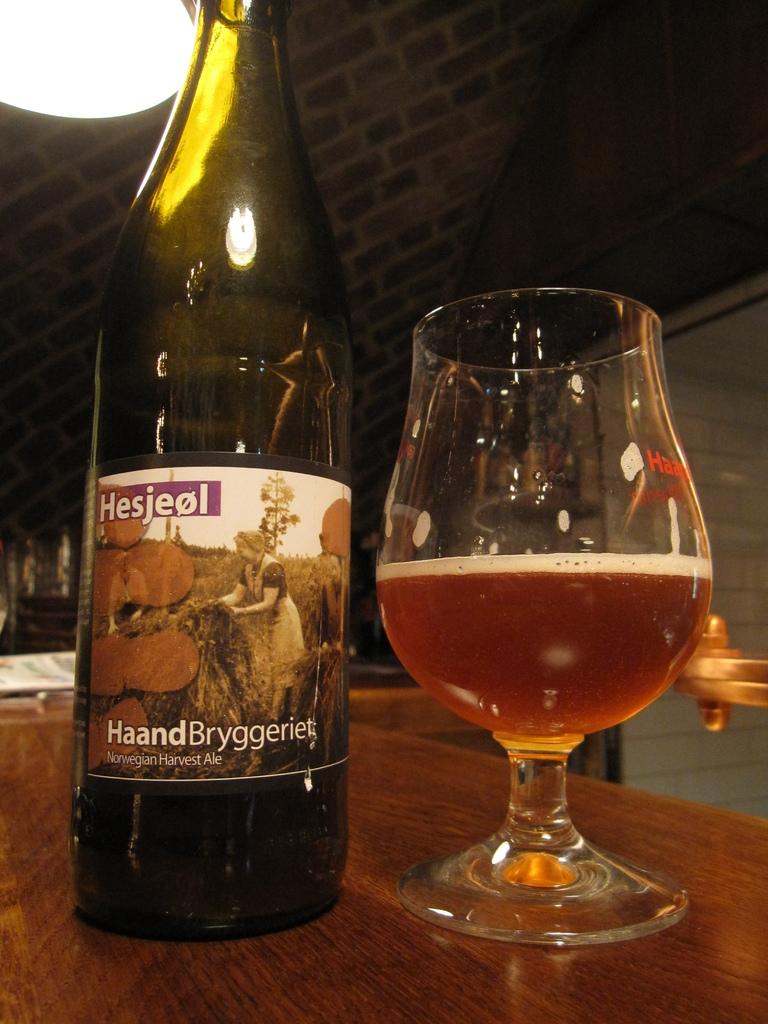What brand is this drink?
Give a very brief answer. Hesjeol. What is the country of the ale?
Offer a very short reply. Norway. 